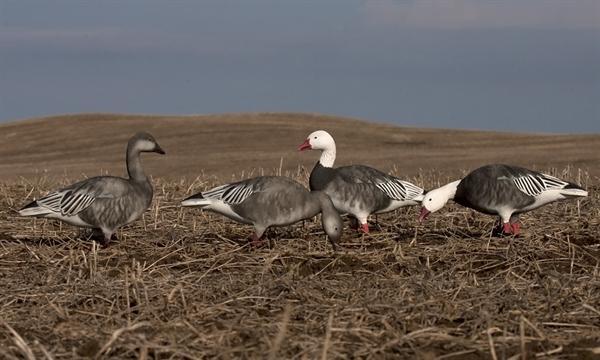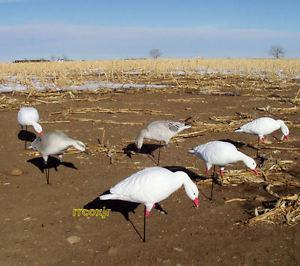The first image is the image on the left, the second image is the image on the right. Analyze the images presented: Is the assertion "The left image includes a row of white and darker grayer duck decoys, and the right image features a white duck decoy closest to the camera." valid? Answer yes or no. Yes. The first image is the image on the left, the second image is the image on the right. For the images shown, is this caption "Two birds in the left image have dark bodies and white heads." true? Answer yes or no. Yes. 